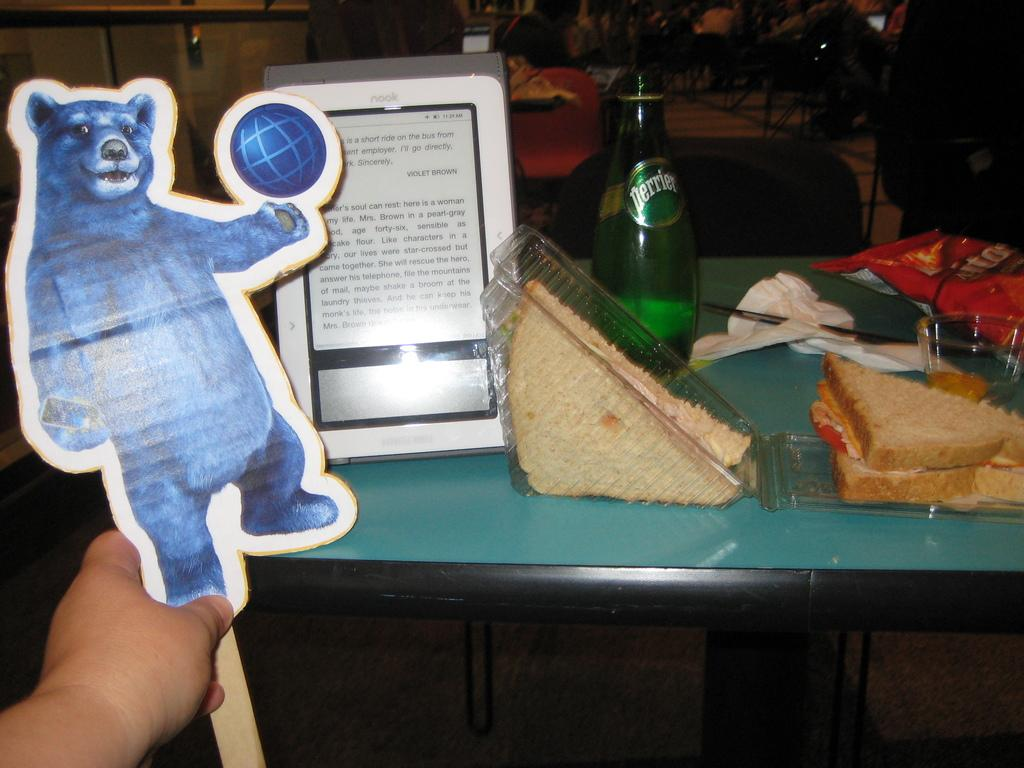<image>
Relay a brief, clear account of the picture shown. A bottle of Perrier sits on a table near a sandwich. 